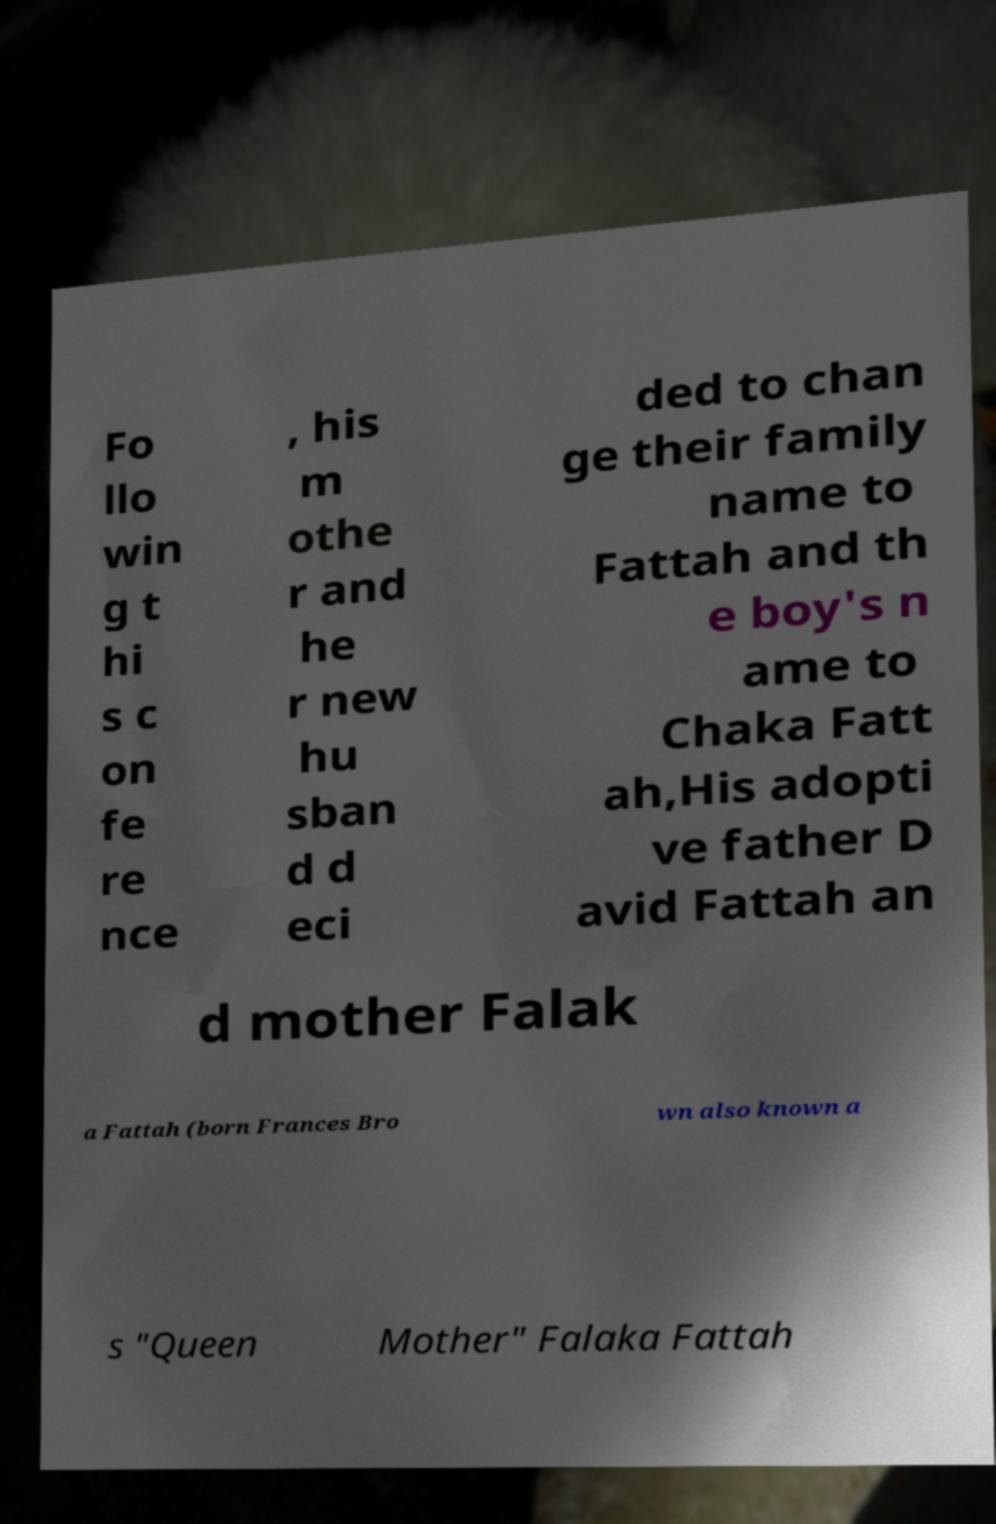Could you assist in decoding the text presented in this image and type it out clearly? Fo llo win g t hi s c on fe re nce , his m othe r and he r new hu sban d d eci ded to chan ge their family name to Fattah and th e boy's n ame to Chaka Fatt ah,His adopti ve father D avid Fattah an d mother Falak a Fattah (born Frances Bro wn also known a s "Queen Mother" Falaka Fattah 